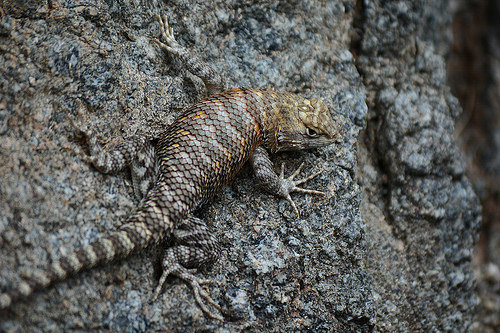<image>
Is the lizard behind the dirt? No. The lizard is not behind the dirt. From this viewpoint, the lizard appears to be positioned elsewhere in the scene. 